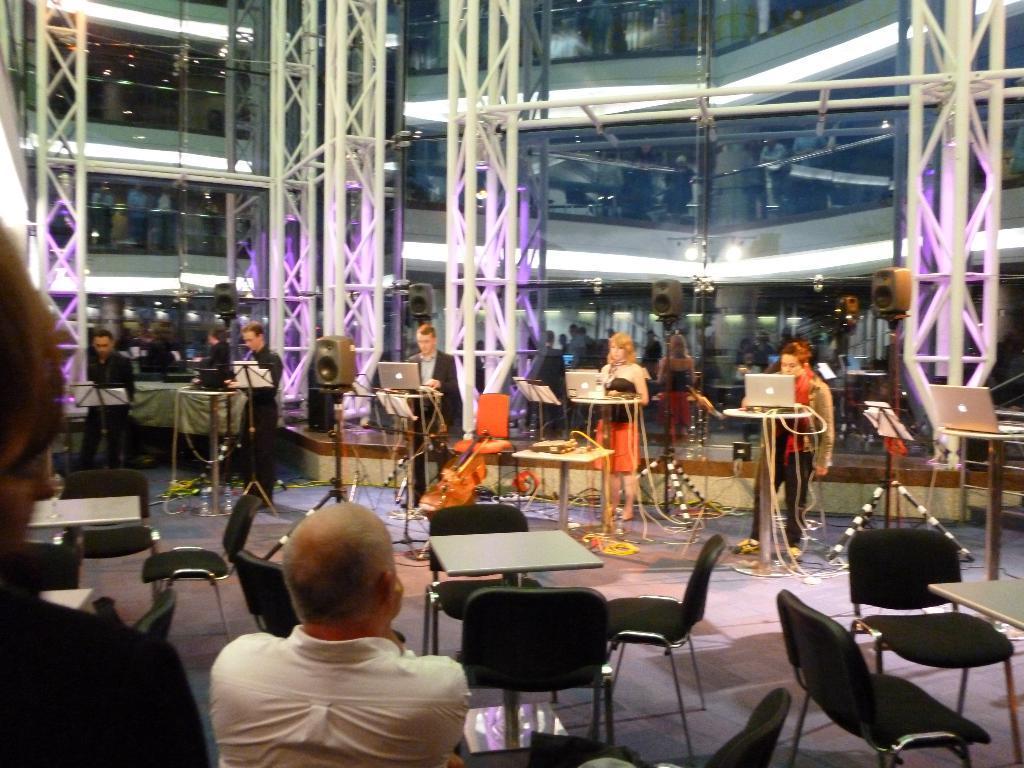How would you summarize this image in a sentence or two? In this picture we can see some persons standing on the floor. These are the chairs and there is a table. Here we can see laptops. On the background there is a glass and this is floor. 